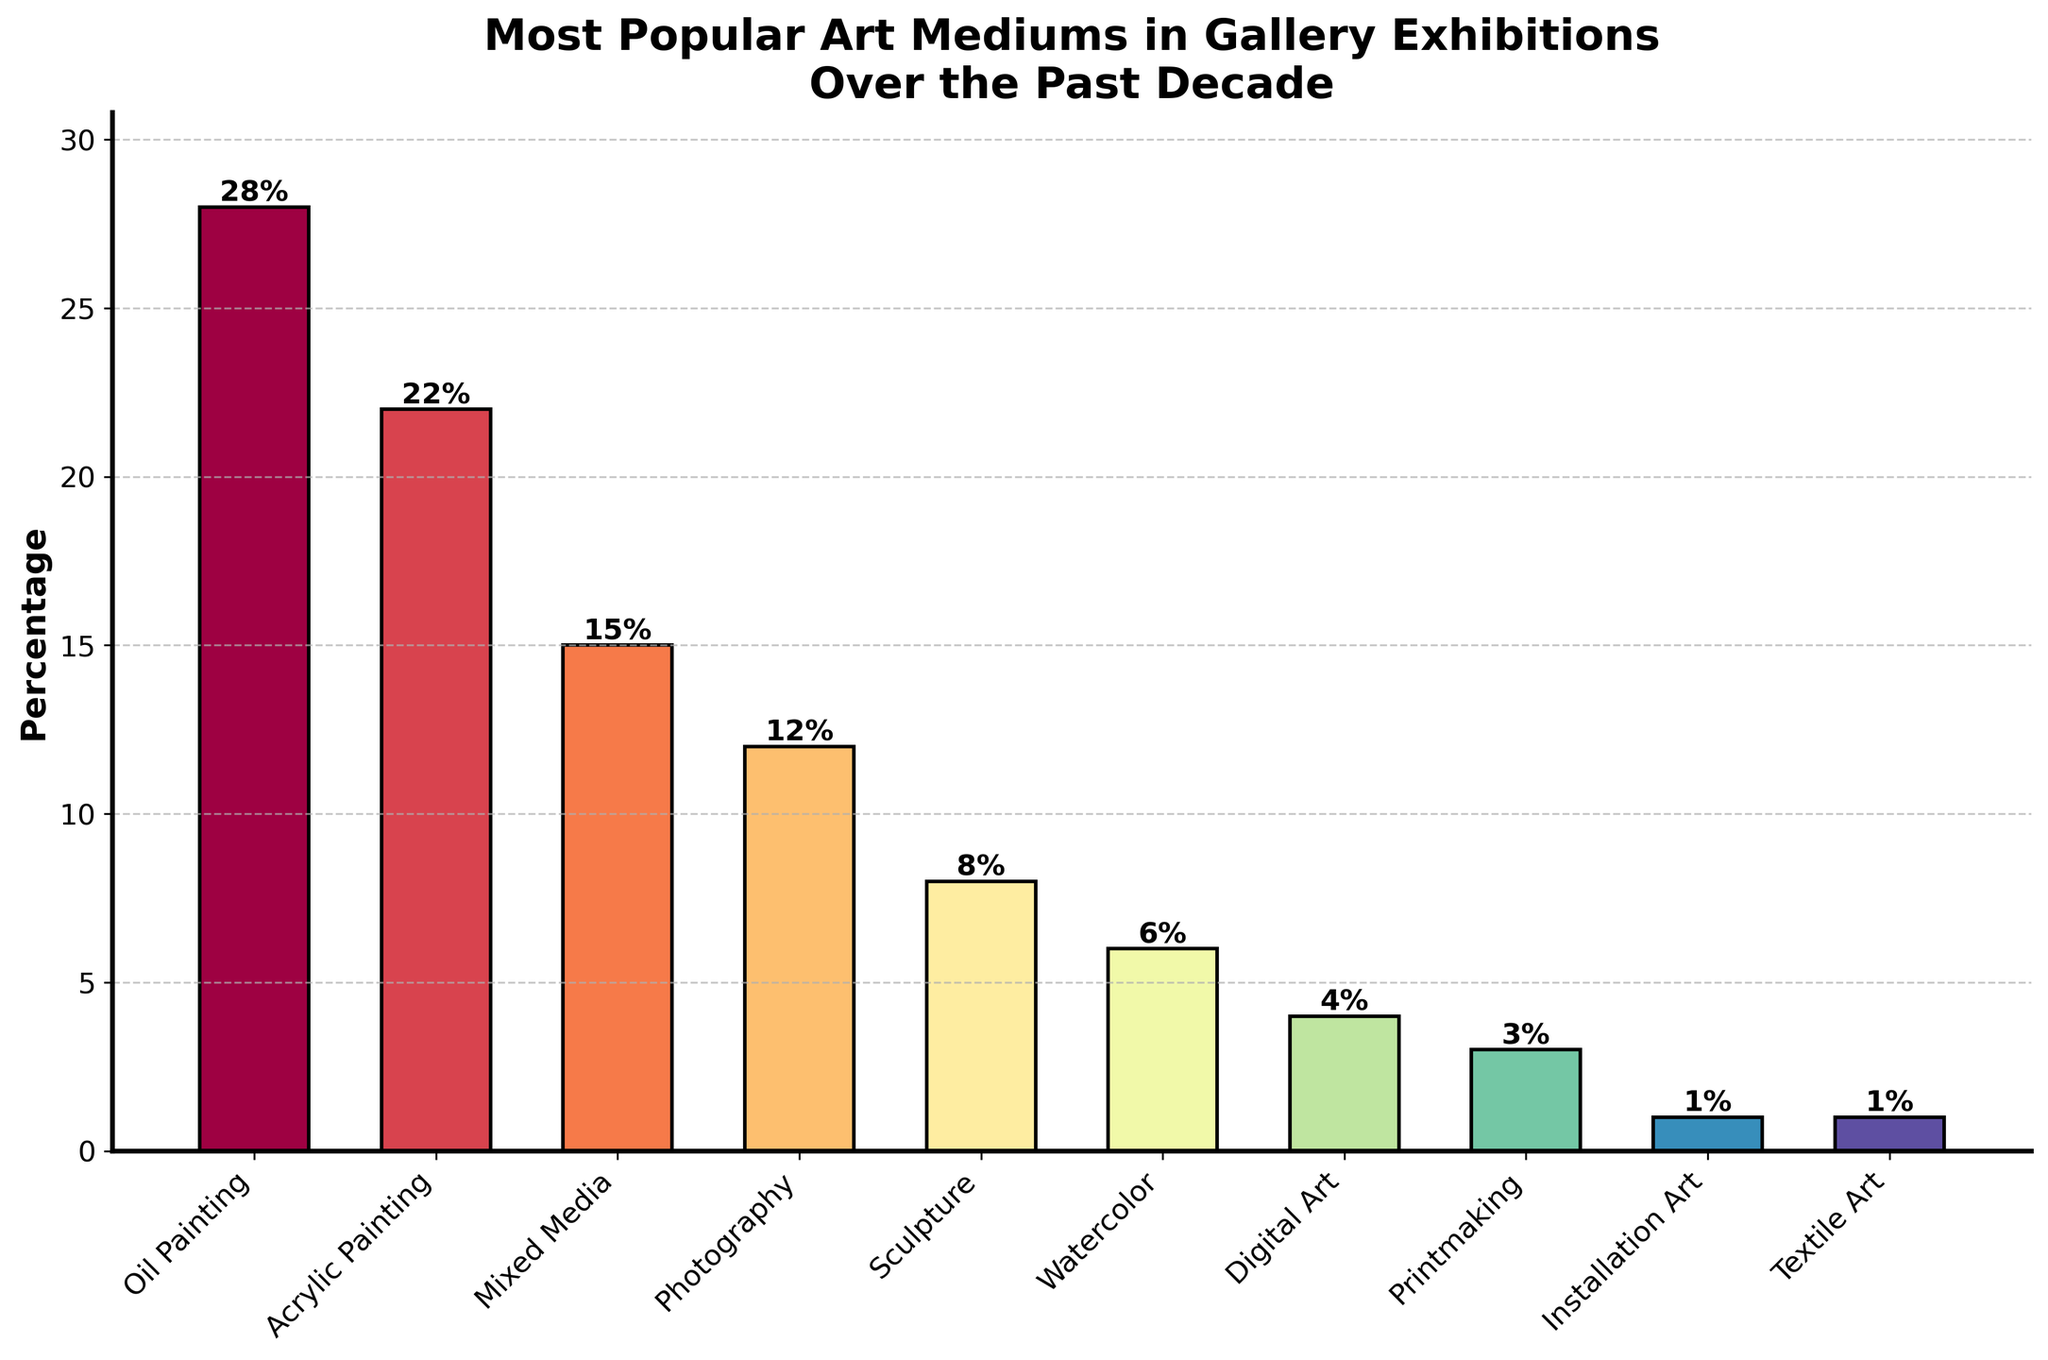What is the most popular art medium used in gallery exhibitions over the past decade? The highest bar on the chart represents the most popular art medium. The tallest bar corresponds to Oil Painting.
Answer: Oil Painting Which art medium has a higher percentage in gallery exhibitions, Photography or Watercolor? To compare the heights of the bars, look at the corresponding percentages. Photography has 12%, while Watercolor has 6%.
Answer: Photography What is the total percentage of art mediums that have less than 10% representation in gallery exhibitions? Identify all art mediums with bar heights less than 10%. These are Sculpture (8%), Watercolor (6%), Digital Art (4%), Printmaking (3%), Installation Art (1%), and Textile Art (1%). Total: 8% + 6% + 4% + 3% + 1% + 1% = 23%.
Answer: 23% Which art mediums have equal representation in gallery exhibitions? Look for bars that have the same height. Installation Art and Textile Art both have bars at 1%.
Answer: Installation Art and Textile Art What is the combined percentage of the top three most popular art mediums? Identify the top three bars: Oil Painting (28%), Acrylic Painting (22%), Mixed Media (15%). Combine them: 28% + 22% + 15% = 65%.
Answer: 65% Which art medium has the lowest popularity, and what percentage does it represent? The shortest bar represents the least popular medium. Both Installation Art and Textile Art are the shortest and both have 1%.
Answer: Installation Art and Textile Art, 1% How much greater is the percentage of Oil Painting compared to Digital Art? Find the difference in percentage between Oil Painting (28%) and Digital Art (4%). The difference is 28% - 4% = 24%.
Answer: 24% What is the average percentage of the art mediums with more than 10% representation? Identify those with more than 10%: Oil Painting (28%), Acrylic Painting (22%), Mixed Media (15%), Photography (12%). Average: (28% + 22% + 15% + 12%) / 4 = 77% / 4 = 19.25%.
Answer: 19.25% If you combine the percentages of Digital Art and Printmaking, how does this total compare to the percentage of Mixed Media? Sum the percentages of Digital Art (4%) and Printmaking (3%), which gives 4% + 3% = 7%. Compare it to Mixed Media's 15%. 7% is less than 15%.
Answer: Less 